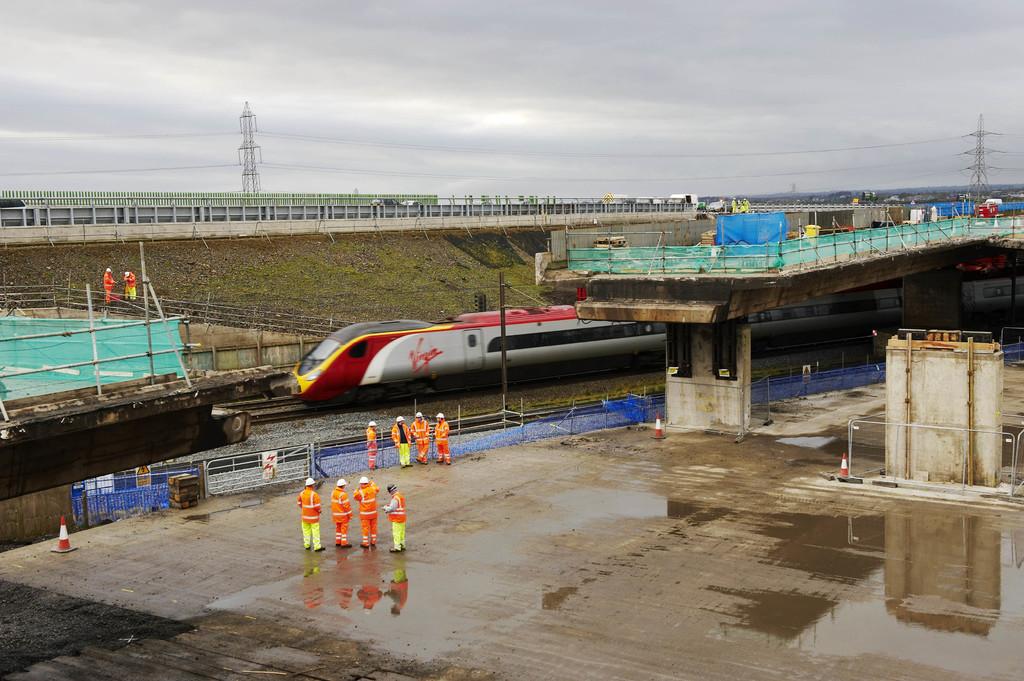What is the name of the train line?
Your answer should be compact. Virgin. 